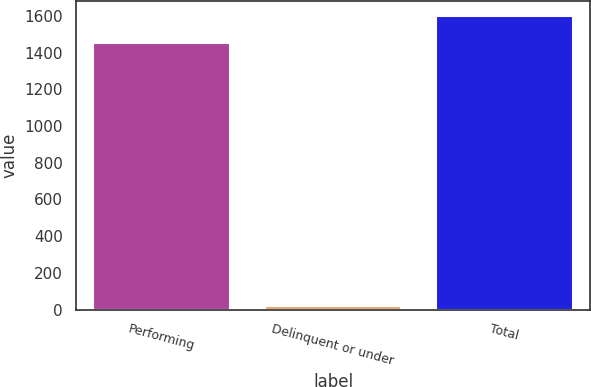Convert chart. <chart><loc_0><loc_0><loc_500><loc_500><bar_chart><fcel>Performing<fcel>Delinquent or under<fcel>Total<nl><fcel>1454<fcel>20<fcel>1600.3<nl></chart> 